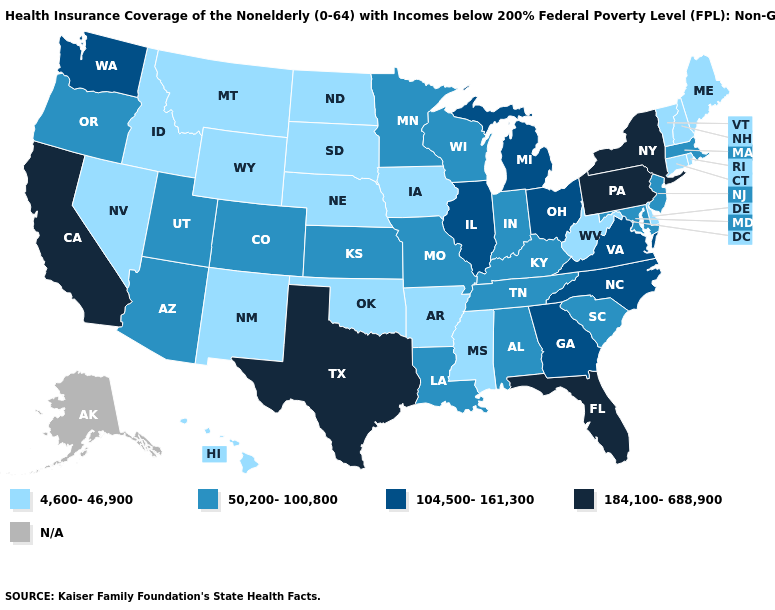Does Pennsylvania have the highest value in the Northeast?
Keep it brief. Yes. Name the states that have a value in the range 184,100-688,900?
Keep it brief. California, Florida, New York, Pennsylvania, Texas. Among the states that border Colorado , which have the highest value?
Keep it brief. Arizona, Kansas, Utah. Name the states that have a value in the range 184,100-688,900?
Short answer required. California, Florida, New York, Pennsylvania, Texas. Does the map have missing data?
Be succinct. Yes. What is the lowest value in states that border Wyoming?
Write a very short answer. 4,600-46,900. Does Idaho have the highest value in the West?
Quick response, please. No. How many symbols are there in the legend?
Answer briefly. 5. What is the highest value in the USA?
Concise answer only. 184,100-688,900. What is the lowest value in the USA?
Answer briefly. 4,600-46,900. Which states have the lowest value in the South?
Answer briefly. Arkansas, Delaware, Mississippi, Oklahoma, West Virginia. Among the states that border Missouri , which have the highest value?
Concise answer only. Illinois. What is the value of South Carolina?
Concise answer only. 50,200-100,800. Which states hav the highest value in the West?
Be succinct. California. Name the states that have a value in the range 184,100-688,900?
Be succinct. California, Florida, New York, Pennsylvania, Texas. 